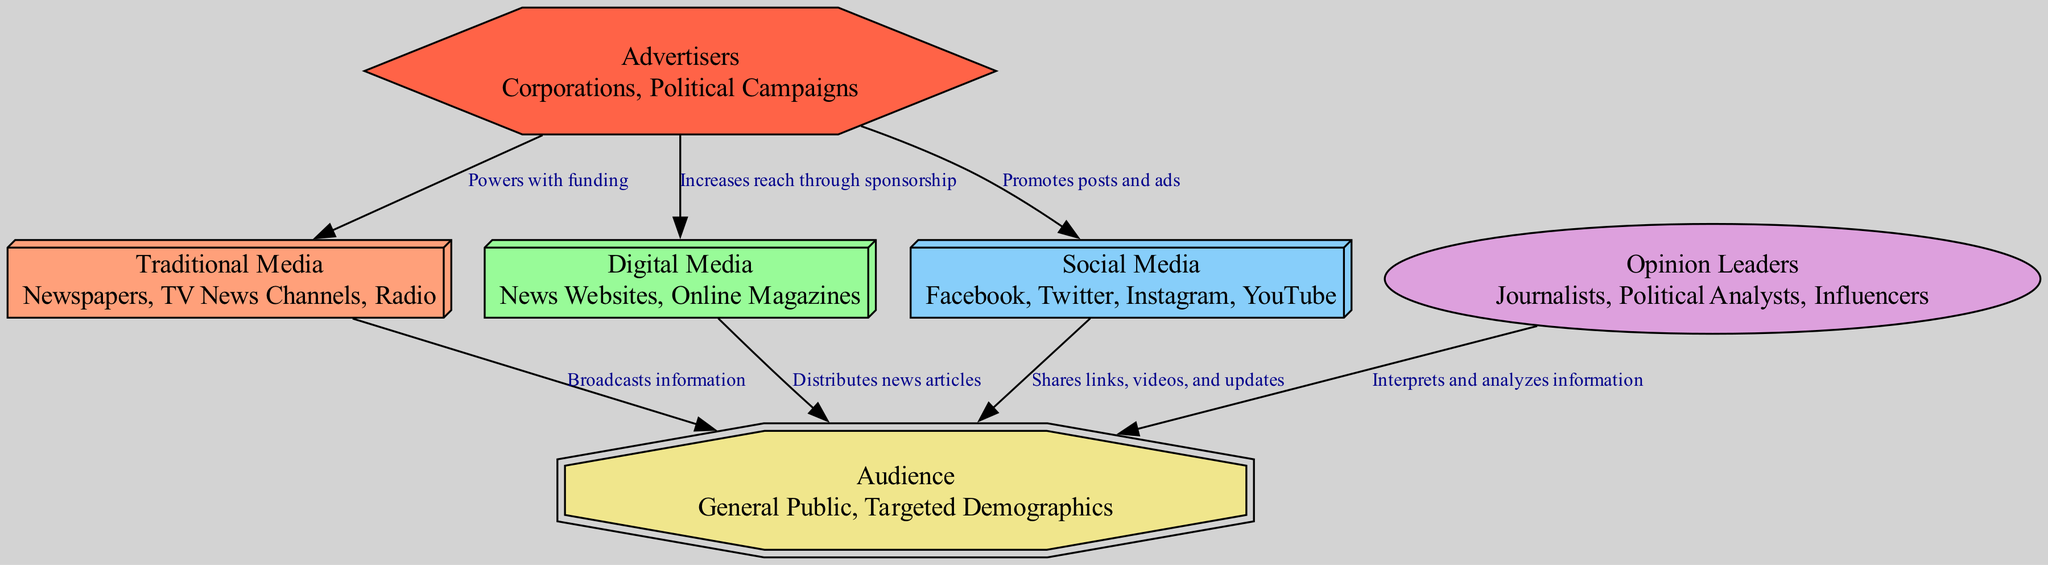What are the examples of traditional media listed in the diagram? The diagram specifies that traditional media includes newspapers, TV news channels, and radio. These are categorized under the node labeled "Traditional Media" along with its description.
Answer: Newspapers, TV News Channels, Radio How many nodes are present in the diagram? The diagram contains six nodes: Traditional Media, Digital Media, Social Media, Opinion Leaders, Audience, and Advertisers. By counting each unique item, we find that there are six in total.
Answer: 6 What is the relationship between digital media and the audience? The arrow connecting digital media to the audience indicates that digital media distributes news articles to the audience. This specific flow demonstrates how information travels from the node of digital media to the audience node.
Answer: Distributes news articles Which type of media shares links, videos, and updates with the audience? The connection shows that social media is responsible for sharing links, videos, and updates to the audience, as indicated in the description of the corresponding edge in the diagram.
Answer: Social Media How do advertisers influence social media according to the diagram? The diagram indicates that advertisers promote posts and ads on social media, showcasing their influence and the method through which they reach the audience. This relationship is depicted through an edge that points from advertisers to social media.
Answer: Promotes posts and ads Which media type has the arrow leading directly to the audience from opinion leaders? The flow from opinion leaders directly points to the audience, illustrating that opinion leaders interpret and analyze information for the audience, marking a clear communication channel from this node to the audience node.
Answer: Opinion Leaders What shape represents traditional media in the diagram? The shape specified for traditional media is a box3d, as per the node styles defined in the code for this particular node type. Consequently, the traditional media node is depicted as a three-dimensional box in the diagram.
Answer: Box3D How do advertisers connect to digital media in the diagram? The edge points from advertisers to digital media, indicating that advertisers increase reach through sponsorship, which establishes their connection to digital media in the overall media network depicted in the diagram.
Answer: Increases reach through sponsorship What role do opinion leaders play in media according to the diagram? The diagram shows that opinion leaders interpret and analyze information for the audience, showcasing their crucial role in mediating political discourse and guiding public opinion through their insights.
Answer: Interprets and analyzes information 